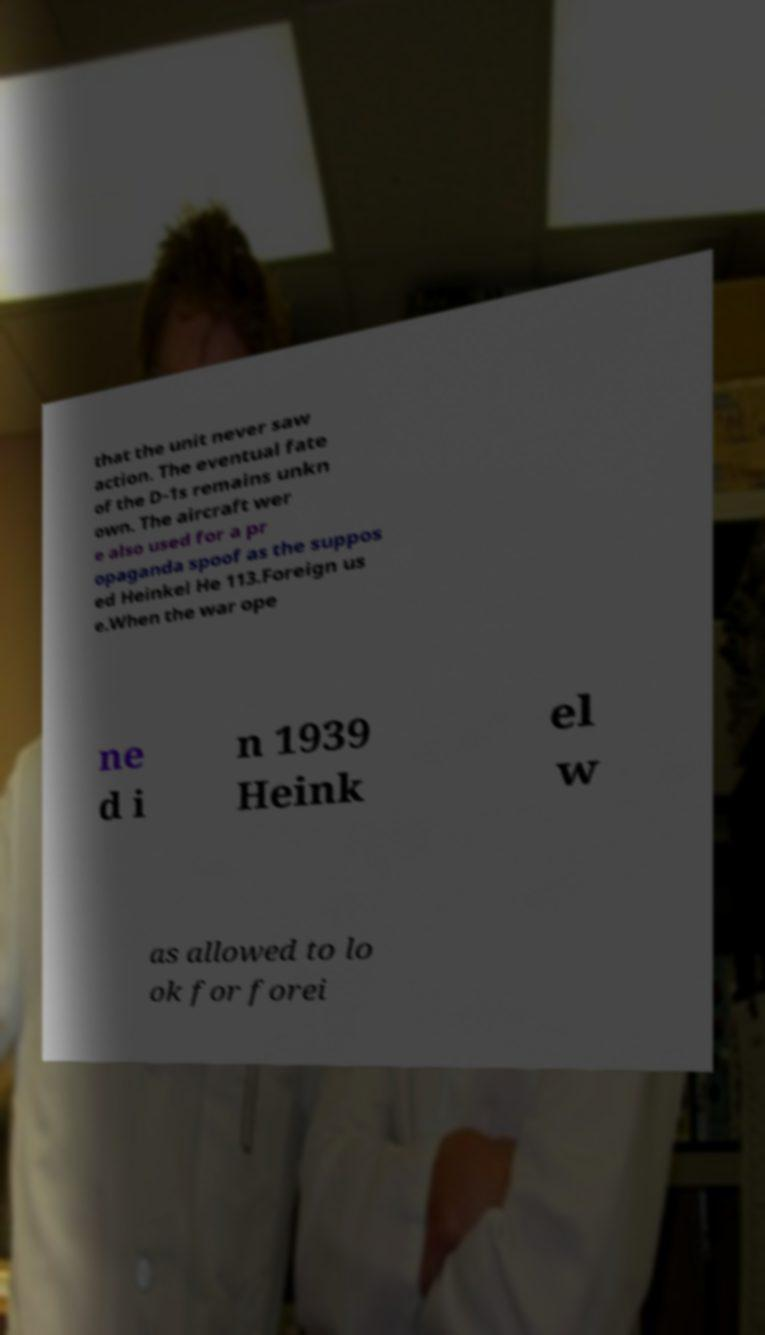Could you extract and type out the text from this image? that the unit never saw action. The eventual fate of the D-1s remains unkn own. The aircraft wer e also used for a pr opaganda spoof as the suppos ed Heinkel He 113.Foreign us e.When the war ope ne d i n 1939 Heink el w as allowed to lo ok for forei 